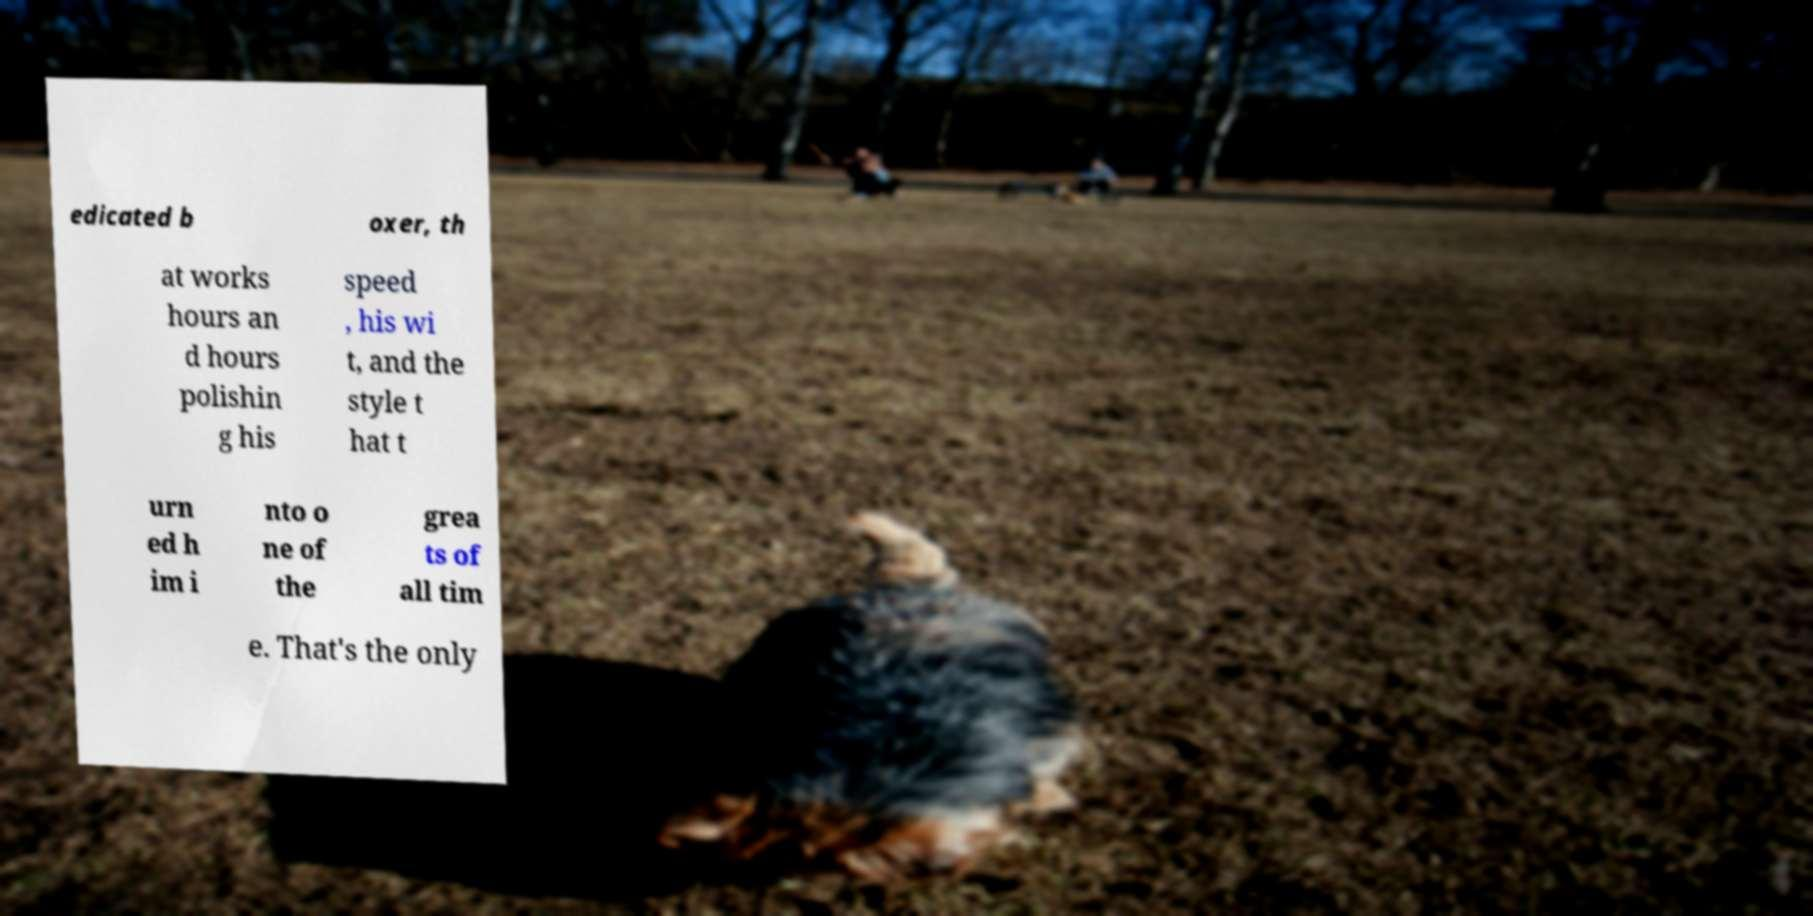I need the written content from this picture converted into text. Can you do that? edicated b oxer, th at works hours an d hours polishin g his speed , his wi t, and the style t hat t urn ed h im i nto o ne of the grea ts of all tim e. That's the only 